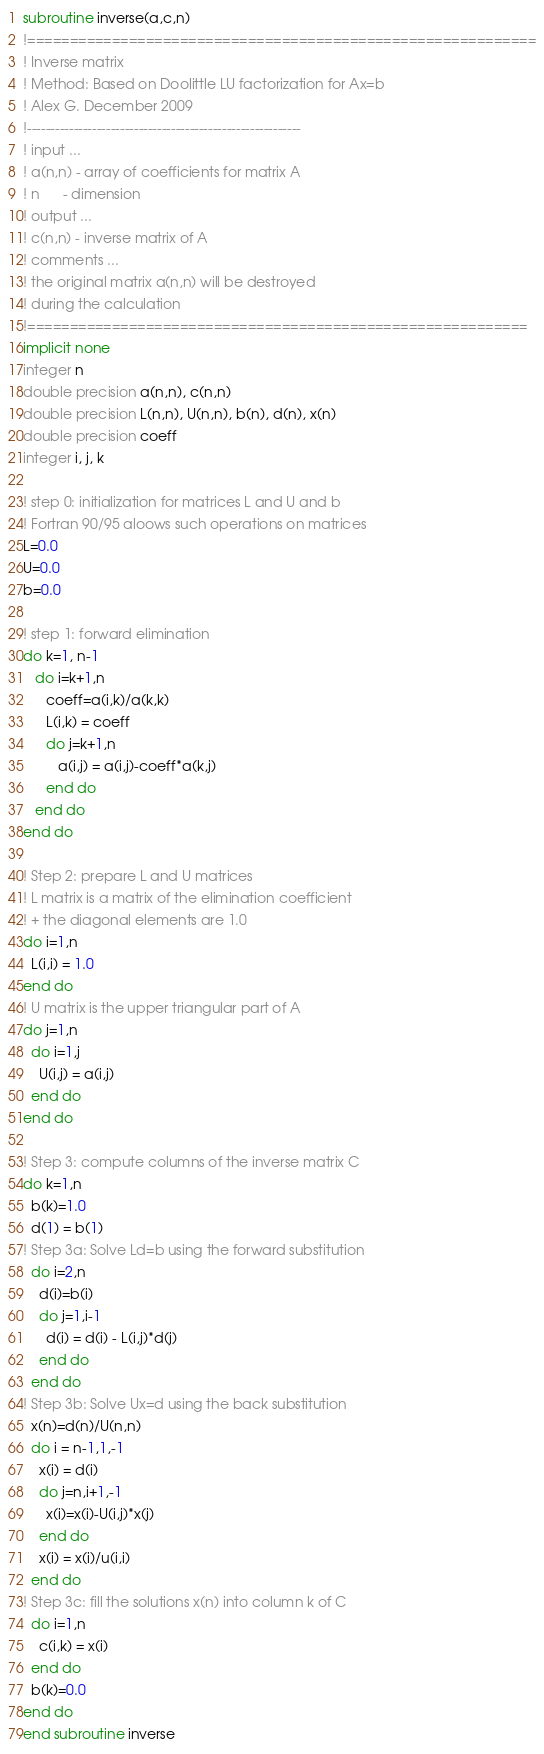Convert code to text. <code><loc_0><loc_0><loc_500><loc_500><_FORTRAN_>subroutine inverse(a,c,n)
!============================================================
! Inverse matrix
! Method: Based on Doolittle LU factorization for Ax=b
! Alex G. December 2009
!-----------------------------------------------------------
! input ...
! a(n,n) - array of coefficients for matrix A
! n      - dimension
! output ...
! c(n,n) - inverse matrix of A
! comments ...
! the original matrix a(n,n) will be destroyed 
! during the calculation
!===========================================================
implicit none 
integer n
double precision a(n,n), c(n,n)
double precision L(n,n), U(n,n), b(n), d(n), x(n)
double precision coeff
integer i, j, k

! step 0: initialization for matrices L and U and b
! Fortran 90/95 aloows such operations on matrices
L=0.0
U=0.0
b=0.0

! step 1: forward elimination
do k=1, n-1
   do i=k+1,n
      coeff=a(i,k)/a(k,k)
      L(i,k) = coeff
      do j=k+1,n
         a(i,j) = a(i,j)-coeff*a(k,j)
      end do
   end do
end do

! Step 2: prepare L and U matrices 
! L matrix is a matrix of the elimination coefficient
! + the diagonal elements are 1.0
do i=1,n
  L(i,i) = 1.0
end do
! U matrix is the upper triangular part of A
do j=1,n
  do i=1,j
    U(i,j) = a(i,j)
  end do
end do

! Step 3: compute columns of the inverse matrix C
do k=1,n
  b(k)=1.0
  d(1) = b(1)
! Step 3a: Solve Ld=b using the forward substitution
  do i=2,n
    d(i)=b(i)
    do j=1,i-1
      d(i) = d(i) - L(i,j)*d(j)
    end do
  end do
! Step 3b: Solve Ux=d using the back substitution
  x(n)=d(n)/U(n,n)
  do i = n-1,1,-1
    x(i) = d(i)
    do j=n,i+1,-1
      x(i)=x(i)-U(i,j)*x(j)
    end do
    x(i) = x(i)/u(i,i)
  end do
! Step 3c: fill the solutions x(n) into column k of C
  do i=1,n
    c(i,k) = x(i)
  end do
  b(k)=0.0
end do
end subroutine inverse
</code> 